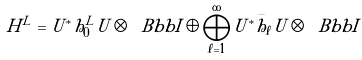Convert formula to latex. <formula><loc_0><loc_0><loc_500><loc_500>H ^ { L } = U ^ { * } h ^ { L } _ { 0 } U \otimes { \ B b b I } \oplus \bigoplus _ { \ell = 1 } ^ { \infty } U ^ { * } \bar { h } _ { \ell } U \otimes { \ B b b I }</formula> 